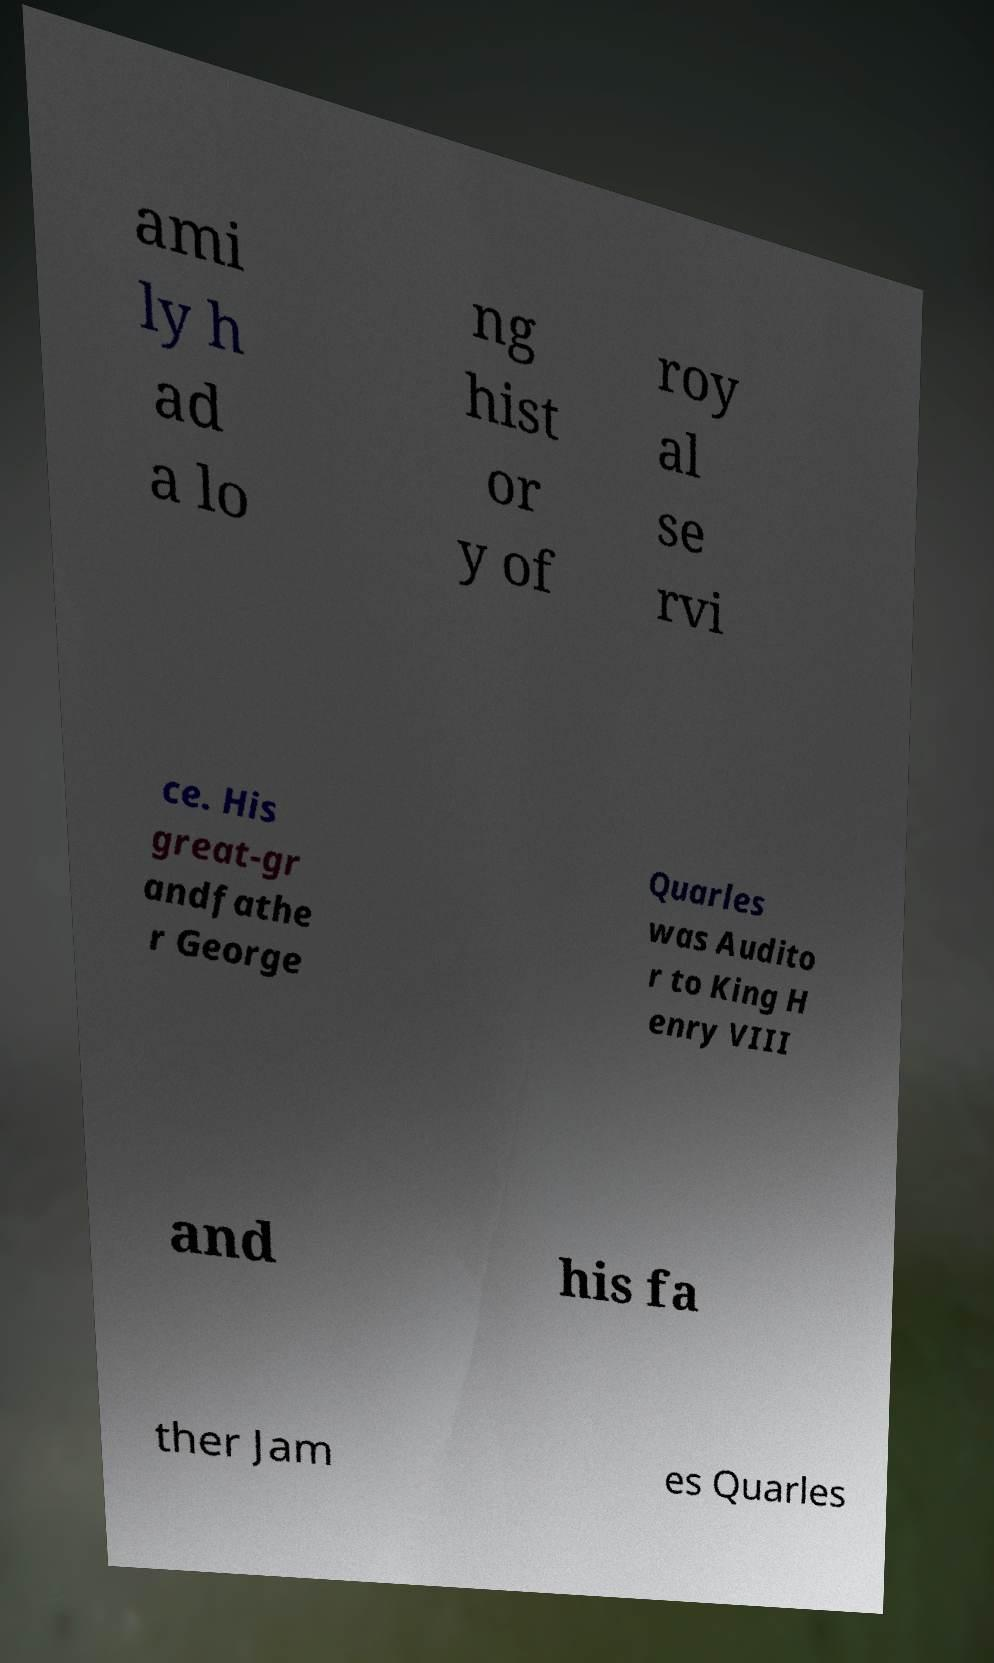Could you extract and type out the text from this image? ami ly h ad a lo ng hist or y of roy al se rvi ce. His great-gr andfathe r George Quarles was Audito r to King H enry VIII and his fa ther Jam es Quarles 